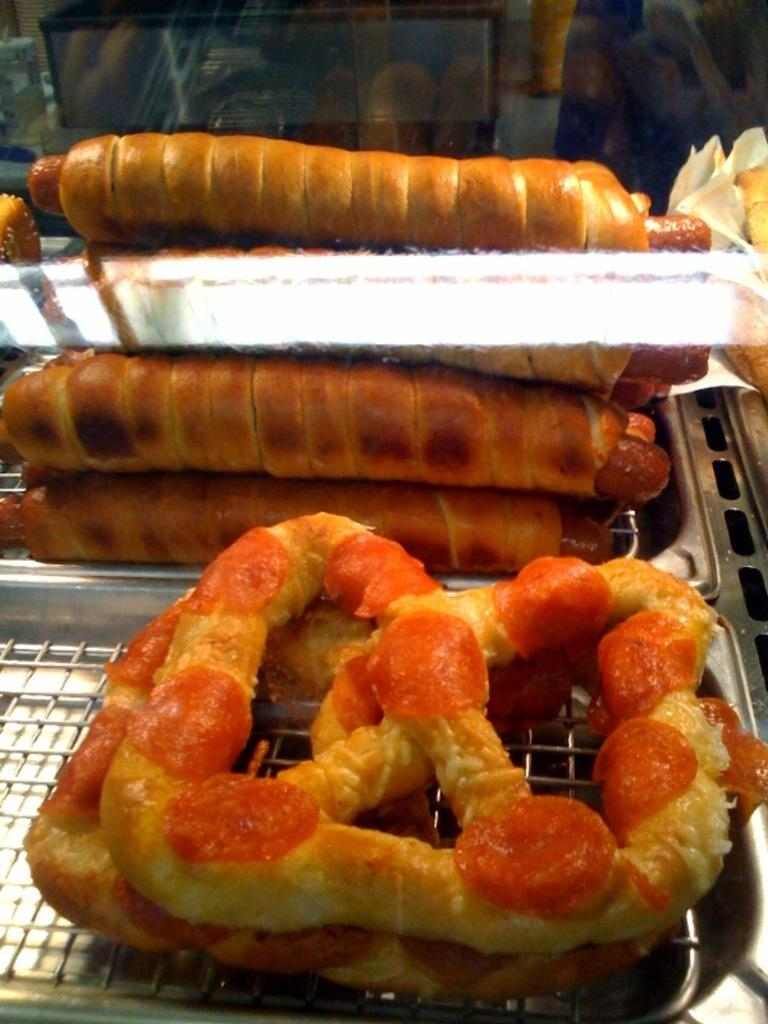What type of food can be seen in the image? The image contains food, but the specific type cannot be determined from the provided facts. What is the primary cooking appliance in the image? There is a grill in the image. What other objects are present in the image besides the food and grill? There are other objects in the image, but their specific nature cannot be determined from the provided facts. How many horses are visible in the image? There are no horses present in the image. What type of train can be seen in the background of the image? There is no train visible in the image. 